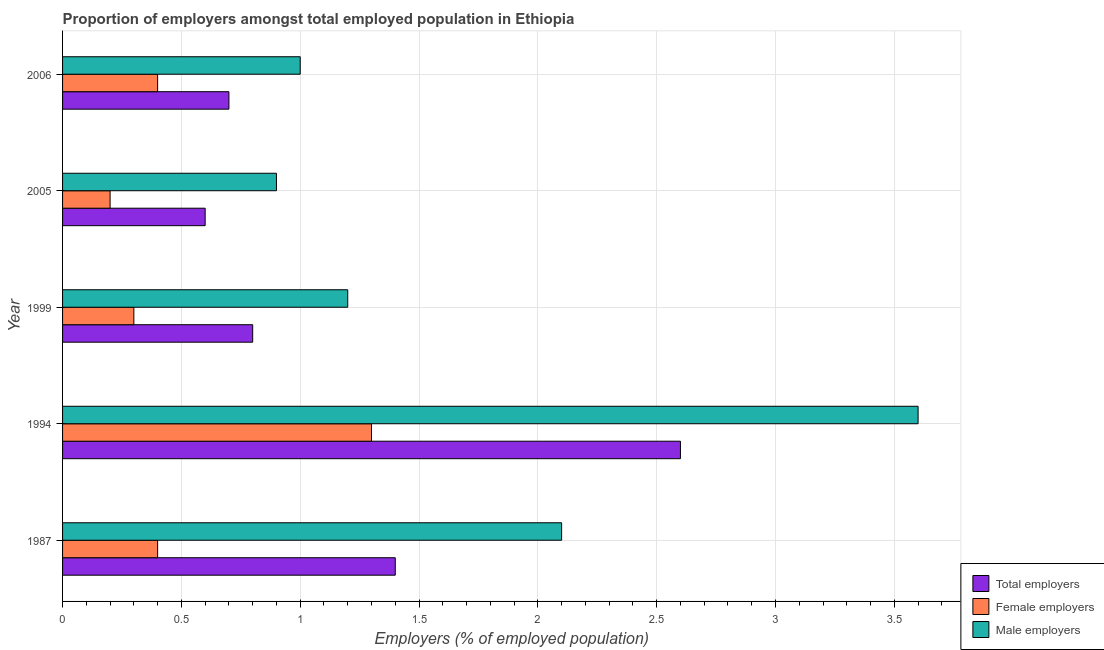How many different coloured bars are there?
Your answer should be compact. 3. How many groups of bars are there?
Offer a terse response. 5. How many bars are there on the 1st tick from the top?
Provide a short and direct response. 3. In how many cases, is the number of bars for a given year not equal to the number of legend labels?
Provide a short and direct response. 0. Across all years, what is the maximum percentage of total employers?
Your response must be concise. 2.6. Across all years, what is the minimum percentage of total employers?
Your answer should be compact. 0.6. In which year was the percentage of male employers maximum?
Your response must be concise. 1994. What is the total percentage of male employers in the graph?
Your answer should be compact. 8.8. What is the difference between the percentage of total employers in 1987 and that in 1999?
Keep it short and to the point. 0.6. What is the difference between the percentage of total employers in 1987 and the percentage of male employers in 2006?
Keep it short and to the point. 0.4. What is the average percentage of male employers per year?
Your answer should be compact. 1.76. In how many years, is the percentage of total employers greater than 3 %?
Make the answer very short. 0. What is the ratio of the percentage of total employers in 1999 to that in 2006?
Keep it short and to the point. 1.14. Is the difference between the percentage of male employers in 1987 and 2005 greater than the difference between the percentage of female employers in 1987 and 2005?
Your response must be concise. Yes. What is the difference between the highest and the second highest percentage of female employers?
Provide a succinct answer. 0.9. What is the difference between the highest and the lowest percentage of female employers?
Provide a succinct answer. 1.1. In how many years, is the percentage of total employers greater than the average percentage of total employers taken over all years?
Give a very brief answer. 2. Is the sum of the percentage of female employers in 1987 and 2006 greater than the maximum percentage of total employers across all years?
Give a very brief answer. No. What does the 1st bar from the top in 1994 represents?
Make the answer very short. Male employers. What does the 1st bar from the bottom in 1994 represents?
Provide a succinct answer. Total employers. How many bars are there?
Provide a succinct answer. 15. Are all the bars in the graph horizontal?
Offer a very short reply. Yes. Are the values on the major ticks of X-axis written in scientific E-notation?
Keep it short and to the point. No. Where does the legend appear in the graph?
Provide a short and direct response. Bottom right. How many legend labels are there?
Offer a very short reply. 3. How are the legend labels stacked?
Ensure brevity in your answer.  Vertical. What is the title of the graph?
Your answer should be very brief. Proportion of employers amongst total employed population in Ethiopia. What is the label or title of the X-axis?
Offer a terse response. Employers (% of employed population). What is the label or title of the Y-axis?
Your answer should be compact. Year. What is the Employers (% of employed population) of Total employers in 1987?
Keep it short and to the point. 1.4. What is the Employers (% of employed population) in Female employers in 1987?
Offer a very short reply. 0.4. What is the Employers (% of employed population) in Male employers in 1987?
Provide a short and direct response. 2.1. What is the Employers (% of employed population) in Total employers in 1994?
Keep it short and to the point. 2.6. What is the Employers (% of employed population) of Female employers in 1994?
Make the answer very short. 1.3. What is the Employers (% of employed population) in Male employers in 1994?
Your response must be concise. 3.6. What is the Employers (% of employed population) of Total employers in 1999?
Offer a terse response. 0.8. What is the Employers (% of employed population) in Female employers in 1999?
Your answer should be very brief. 0.3. What is the Employers (% of employed population) of Male employers in 1999?
Your response must be concise. 1.2. What is the Employers (% of employed population) in Total employers in 2005?
Keep it short and to the point. 0.6. What is the Employers (% of employed population) in Female employers in 2005?
Offer a very short reply. 0.2. What is the Employers (% of employed population) of Male employers in 2005?
Provide a short and direct response. 0.9. What is the Employers (% of employed population) in Total employers in 2006?
Ensure brevity in your answer.  0.7. What is the Employers (% of employed population) in Female employers in 2006?
Ensure brevity in your answer.  0.4. What is the Employers (% of employed population) in Male employers in 2006?
Offer a very short reply. 1. Across all years, what is the maximum Employers (% of employed population) of Total employers?
Keep it short and to the point. 2.6. Across all years, what is the maximum Employers (% of employed population) of Female employers?
Provide a short and direct response. 1.3. Across all years, what is the maximum Employers (% of employed population) of Male employers?
Offer a very short reply. 3.6. Across all years, what is the minimum Employers (% of employed population) of Total employers?
Give a very brief answer. 0.6. Across all years, what is the minimum Employers (% of employed population) of Female employers?
Your response must be concise. 0.2. Across all years, what is the minimum Employers (% of employed population) in Male employers?
Give a very brief answer. 0.9. What is the total Employers (% of employed population) in Female employers in the graph?
Your answer should be compact. 2.6. What is the difference between the Employers (% of employed population) of Female employers in 1987 and that in 1994?
Offer a very short reply. -0.9. What is the difference between the Employers (% of employed population) in Male employers in 1987 and that in 1994?
Provide a short and direct response. -1.5. What is the difference between the Employers (% of employed population) of Total employers in 1987 and that in 1999?
Give a very brief answer. 0.6. What is the difference between the Employers (% of employed population) in Male employers in 1987 and that in 1999?
Your response must be concise. 0.9. What is the difference between the Employers (% of employed population) of Total employers in 1987 and that in 2005?
Your response must be concise. 0.8. What is the difference between the Employers (% of employed population) of Female employers in 1987 and that in 2006?
Provide a short and direct response. 0. What is the difference between the Employers (% of employed population) of Total employers in 1994 and that in 1999?
Provide a short and direct response. 1.8. What is the difference between the Employers (% of employed population) of Female employers in 1994 and that in 1999?
Your answer should be compact. 1. What is the difference between the Employers (% of employed population) in Male employers in 1994 and that in 1999?
Your response must be concise. 2.4. What is the difference between the Employers (% of employed population) of Total employers in 1994 and that in 2005?
Keep it short and to the point. 2. What is the difference between the Employers (% of employed population) of Male employers in 1994 and that in 2005?
Offer a terse response. 2.7. What is the difference between the Employers (% of employed population) of Total employers in 1994 and that in 2006?
Ensure brevity in your answer.  1.9. What is the difference between the Employers (% of employed population) of Female employers in 1994 and that in 2006?
Provide a succinct answer. 0.9. What is the difference between the Employers (% of employed population) in Male employers in 1999 and that in 2005?
Your answer should be compact. 0.3. What is the difference between the Employers (% of employed population) of Female employers in 1999 and that in 2006?
Ensure brevity in your answer.  -0.1. What is the difference between the Employers (% of employed population) of Male employers in 1999 and that in 2006?
Your answer should be compact. 0.2. What is the difference between the Employers (% of employed population) of Total employers in 2005 and that in 2006?
Your answer should be very brief. -0.1. What is the difference between the Employers (% of employed population) of Male employers in 2005 and that in 2006?
Provide a short and direct response. -0.1. What is the difference between the Employers (% of employed population) in Total employers in 1987 and the Employers (% of employed population) in Female employers in 1994?
Keep it short and to the point. 0.1. What is the difference between the Employers (% of employed population) in Female employers in 1987 and the Employers (% of employed population) in Male employers in 1994?
Offer a terse response. -3.2. What is the difference between the Employers (% of employed population) in Total employers in 1987 and the Employers (% of employed population) in Male employers in 1999?
Give a very brief answer. 0.2. What is the difference between the Employers (% of employed population) of Female employers in 1987 and the Employers (% of employed population) of Male employers in 1999?
Your answer should be compact. -0.8. What is the difference between the Employers (% of employed population) in Female employers in 1994 and the Employers (% of employed population) in Male employers in 1999?
Give a very brief answer. 0.1. What is the difference between the Employers (% of employed population) of Total employers in 1994 and the Employers (% of employed population) of Male employers in 2005?
Your answer should be very brief. 1.7. What is the difference between the Employers (% of employed population) in Total employers in 1999 and the Employers (% of employed population) in Female employers in 2005?
Provide a succinct answer. 0.6. What is the difference between the Employers (% of employed population) in Female employers in 1999 and the Employers (% of employed population) in Male employers in 2005?
Your response must be concise. -0.6. What is the difference between the Employers (% of employed population) in Total employers in 1999 and the Employers (% of employed population) in Male employers in 2006?
Your answer should be compact. -0.2. What is the difference between the Employers (% of employed population) of Total employers in 2005 and the Employers (% of employed population) of Female employers in 2006?
Keep it short and to the point. 0.2. What is the difference between the Employers (% of employed population) in Female employers in 2005 and the Employers (% of employed population) in Male employers in 2006?
Make the answer very short. -0.8. What is the average Employers (% of employed population) in Total employers per year?
Make the answer very short. 1.22. What is the average Employers (% of employed population) in Female employers per year?
Provide a short and direct response. 0.52. What is the average Employers (% of employed population) of Male employers per year?
Offer a terse response. 1.76. In the year 1987, what is the difference between the Employers (% of employed population) of Total employers and Employers (% of employed population) of Female employers?
Provide a short and direct response. 1. In the year 1987, what is the difference between the Employers (% of employed population) in Female employers and Employers (% of employed population) in Male employers?
Give a very brief answer. -1.7. In the year 1994, what is the difference between the Employers (% of employed population) in Total employers and Employers (% of employed population) in Male employers?
Offer a very short reply. -1. In the year 1999, what is the difference between the Employers (% of employed population) in Female employers and Employers (% of employed population) in Male employers?
Provide a succinct answer. -0.9. In the year 2005, what is the difference between the Employers (% of employed population) in Total employers and Employers (% of employed population) in Male employers?
Keep it short and to the point. -0.3. In the year 2005, what is the difference between the Employers (% of employed population) in Female employers and Employers (% of employed population) in Male employers?
Offer a very short reply. -0.7. In the year 2006, what is the difference between the Employers (% of employed population) in Total employers and Employers (% of employed population) in Female employers?
Your answer should be very brief. 0.3. What is the ratio of the Employers (% of employed population) in Total employers in 1987 to that in 1994?
Keep it short and to the point. 0.54. What is the ratio of the Employers (% of employed population) of Female employers in 1987 to that in 1994?
Offer a very short reply. 0.31. What is the ratio of the Employers (% of employed population) in Male employers in 1987 to that in 1994?
Provide a short and direct response. 0.58. What is the ratio of the Employers (% of employed population) in Male employers in 1987 to that in 1999?
Provide a short and direct response. 1.75. What is the ratio of the Employers (% of employed population) in Total employers in 1987 to that in 2005?
Offer a very short reply. 2.33. What is the ratio of the Employers (% of employed population) of Female employers in 1987 to that in 2005?
Keep it short and to the point. 2. What is the ratio of the Employers (% of employed population) of Male employers in 1987 to that in 2005?
Offer a terse response. 2.33. What is the ratio of the Employers (% of employed population) of Total employers in 1987 to that in 2006?
Your answer should be compact. 2. What is the ratio of the Employers (% of employed population) in Total employers in 1994 to that in 1999?
Keep it short and to the point. 3.25. What is the ratio of the Employers (% of employed population) in Female employers in 1994 to that in 1999?
Offer a very short reply. 4.33. What is the ratio of the Employers (% of employed population) of Male employers in 1994 to that in 1999?
Make the answer very short. 3. What is the ratio of the Employers (% of employed population) in Total employers in 1994 to that in 2005?
Offer a very short reply. 4.33. What is the ratio of the Employers (% of employed population) in Male employers in 1994 to that in 2005?
Your answer should be compact. 4. What is the ratio of the Employers (% of employed population) in Total employers in 1994 to that in 2006?
Provide a short and direct response. 3.71. What is the ratio of the Employers (% of employed population) of Male employers in 1994 to that in 2006?
Your response must be concise. 3.6. What is the ratio of the Employers (% of employed population) in Female employers in 1999 to that in 2005?
Your response must be concise. 1.5. What is the ratio of the Employers (% of employed population) in Male employers in 1999 to that in 2005?
Your answer should be compact. 1.33. What is the ratio of the Employers (% of employed population) in Total employers in 1999 to that in 2006?
Your response must be concise. 1.14. What is the ratio of the Employers (% of employed population) of Female employers in 1999 to that in 2006?
Offer a very short reply. 0.75. What is the ratio of the Employers (% of employed population) of Male employers in 1999 to that in 2006?
Give a very brief answer. 1.2. What is the difference between the highest and the second highest Employers (% of employed population) of Total employers?
Offer a very short reply. 1.2. What is the difference between the highest and the second highest Employers (% of employed population) of Female employers?
Make the answer very short. 0.9. What is the difference between the highest and the second highest Employers (% of employed population) in Male employers?
Make the answer very short. 1.5. What is the difference between the highest and the lowest Employers (% of employed population) in Total employers?
Provide a short and direct response. 2. What is the difference between the highest and the lowest Employers (% of employed population) in Female employers?
Provide a short and direct response. 1.1. 